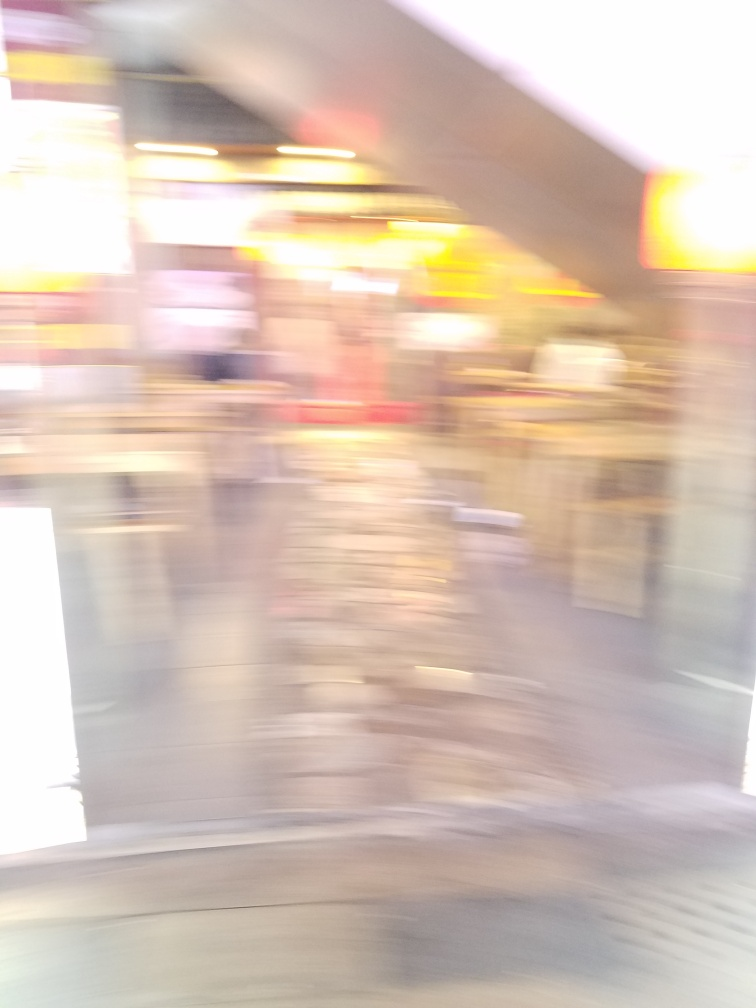Could you guess the type of location where this photograph was taken? Given the mix of bright and muted colors, the blurriness suggesting movement, and the vertical and horizontal lines that hint at structure, it's plausible the photo was taken inside an urban space, such as a street or a commercial area, where lights and the motion of people are common. What kind of activities do you think typically happen in this location? If the guess about the urban and possibly commercial setting is accurate, typical activities might include shopping, dining, people commuting, or simply walking through. The area may be busy with the hustle and bustle of city life, contributing to the dynamic feel of the captured moment. 